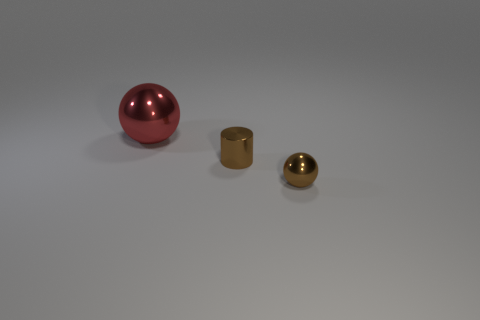How many metallic cylinders are there?
Your answer should be compact. 1. What is the shape of the large object?
Your response must be concise. Sphere. What number of balls have the same size as the cylinder?
Make the answer very short. 1. There is a ball in front of the ball that is behind the brown sphere; what is its color?
Give a very brief answer. Brown. What is the size of the metal object that is both behind the small brown shiny ball and in front of the red ball?
Your answer should be very brief. Small. Is there anything else that is the same color as the cylinder?
Give a very brief answer. Yes. There is a small brown object that is made of the same material as the brown ball; what shape is it?
Provide a short and direct response. Cylinder. There is a red metallic thing; is its shape the same as the small thing in front of the small brown cylinder?
Offer a terse response. Yes. What material is the sphere behind the metal ball on the right side of the brown metal cylinder made of?
Your response must be concise. Metal. Are there the same number of brown objects in front of the small shiny sphere and metallic things?
Your answer should be very brief. No. 